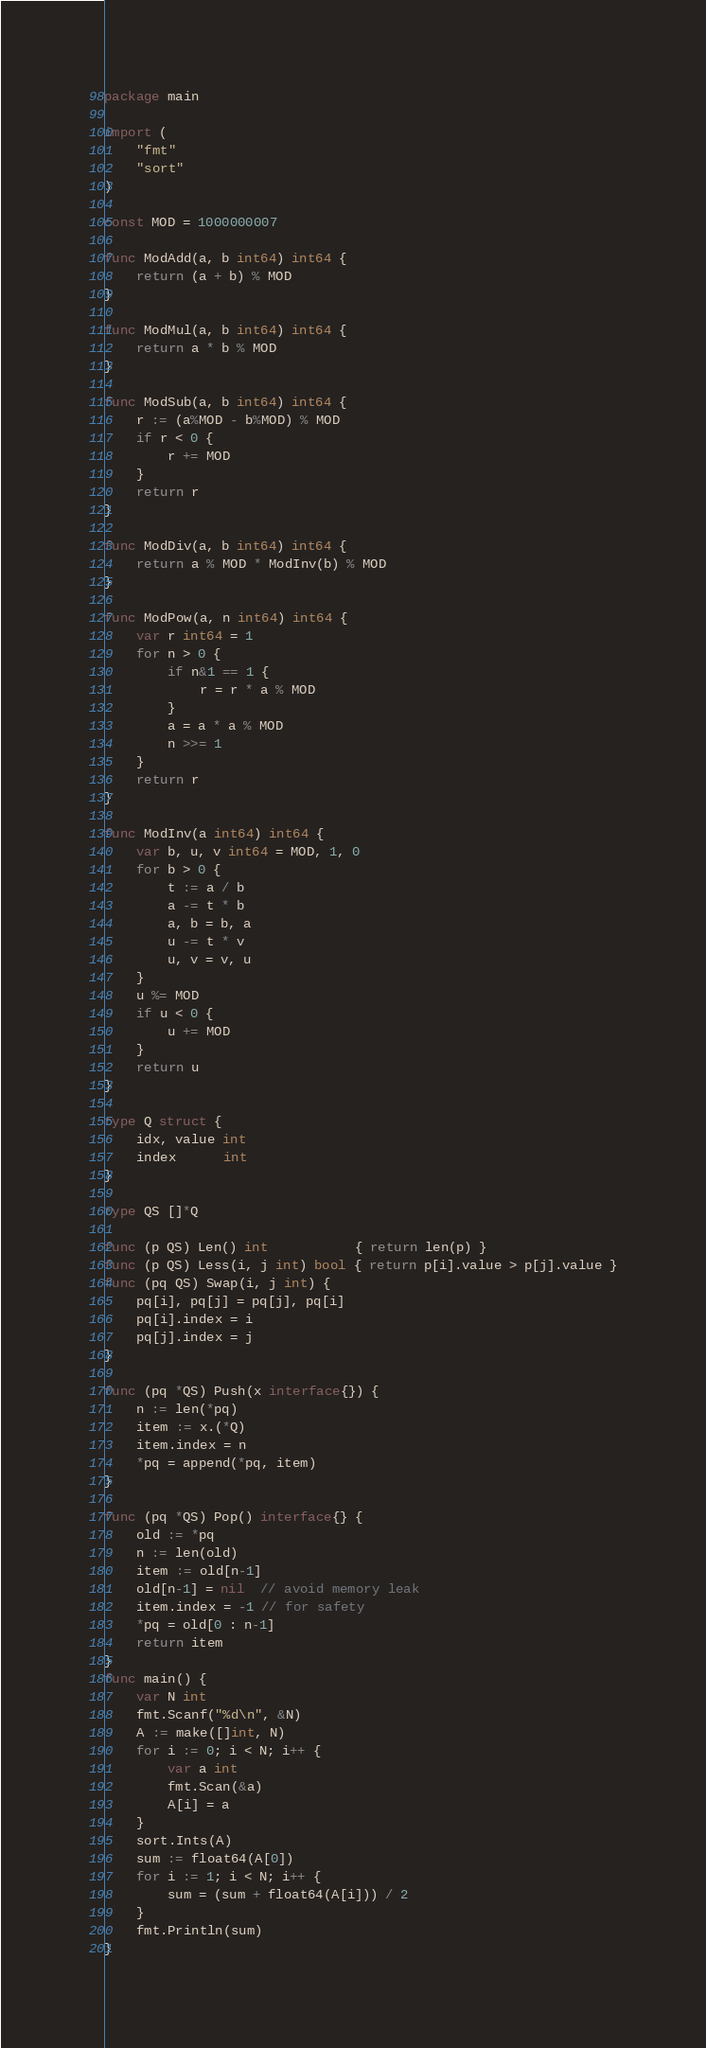<code> <loc_0><loc_0><loc_500><loc_500><_Go_>package main

import (
	"fmt"
	"sort"
)

const MOD = 1000000007

func ModAdd(a, b int64) int64 {
	return (a + b) % MOD
}

func ModMul(a, b int64) int64 {
	return a * b % MOD
}

func ModSub(a, b int64) int64 {
	r := (a%MOD - b%MOD) % MOD
	if r < 0 {
		r += MOD
	}
	return r
}

func ModDiv(a, b int64) int64 {
	return a % MOD * ModInv(b) % MOD
}

func ModPow(a, n int64) int64 {
	var r int64 = 1
	for n > 0 {
		if n&1 == 1 {
			r = r * a % MOD
		}
		a = a * a % MOD
		n >>= 1
	}
	return r
}

func ModInv(a int64) int64 {
	var b, u, v int64 = MOD, 1, 0
	for b > 0 {
		t := a / b
		a -= t * b
		a, b = b, a
		u -= t * v
		u, v = v, u
	}
	u %= MOD
	if u < 0 {
		u += MOD
	}
	return u
}

type Q struct {
	idx, value int
	index      int
}

type QS []*Q

func (p QS) Len() int           { return len(p) }
func (p QS) Less(i, j int) bool { return p[i].value > p[j].value }
func (pq QS) Swap(i, j int) {
	pq[i], pq[j] = pq[j], pq[i]
	pq[i].index = i
	pq[j].index = j
}

func (pq *QS) Push(x interface{}) {
	n := len(*pq)
	item := x.(*Q)
	item.index = n
	*pq = append(*pq, item)
}

func (pq *QS) Pop() interface{} {
	old := *pq
	n := len(old)
	item := old[n-1]
	old[n-1] = nil  // avoid memory leak
	item.index = -1 // for safety
	*pq = old[0 : n-1]
	return item
}
func main() {
	var N int
	fmt.Scanf("%d\n", &N)
	A := make([]int, N)
	for i := 0; i < N; i++ {
		var a int
		fmt.Scan(&a)
		A[i] = a
	}
	sort.Ints(A)
	sum := float64(A[0])
	for i := 1; i < N; i++ {
		sum = (sum + float64(A[i])) / 2
	}
	fmt.Println(sum)
}
</code> 